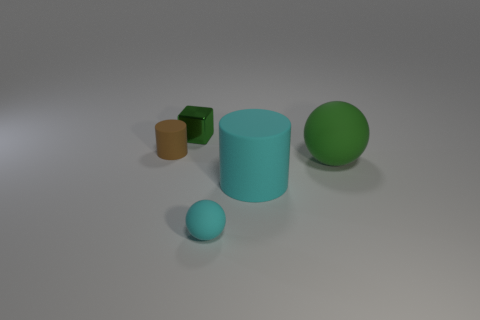Are there any other things that have the same material as the tiny cube?
Give a very brief answer. No. What number of small objects have the same material as the large cyan thing?
Keep it short and to the point. 2. What is the shape of the cyan matte thing to the right of the tiny rubber ball?
Provide a short and direct response. Cylinder. Does the green thing that is left of the cyan matte sphere have the same material as the tiny thing that is to the left of the metallic thing?
Make the answer very short. No. Are there any other tiny brown things of the same shape as the metal thing?
Your response must be concise. No. How many objects are small things that are behind the small brown thing or tiny balls?
Offer a very short reply. 2. Is the number of tiny green blocks in front of the big green sphere greater than the number of cyan objects to the right of the large rubber cylinder?
Your answer should be compact. No. How many metal things are either tiny blocks or large cyan objects?
Provide a succinct answer. 1. What is the material of the thing that is the same color as the metallic block?
Provide a succinct answer. Rubber. Is the number of cyan things that are behind the green matte thing less than the number of small cyan balls that are to the right of the cyan matte cylinder?
Ensure brevity in your answer.  No. 